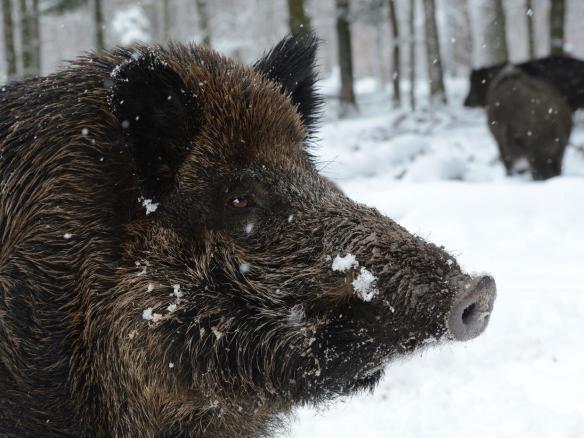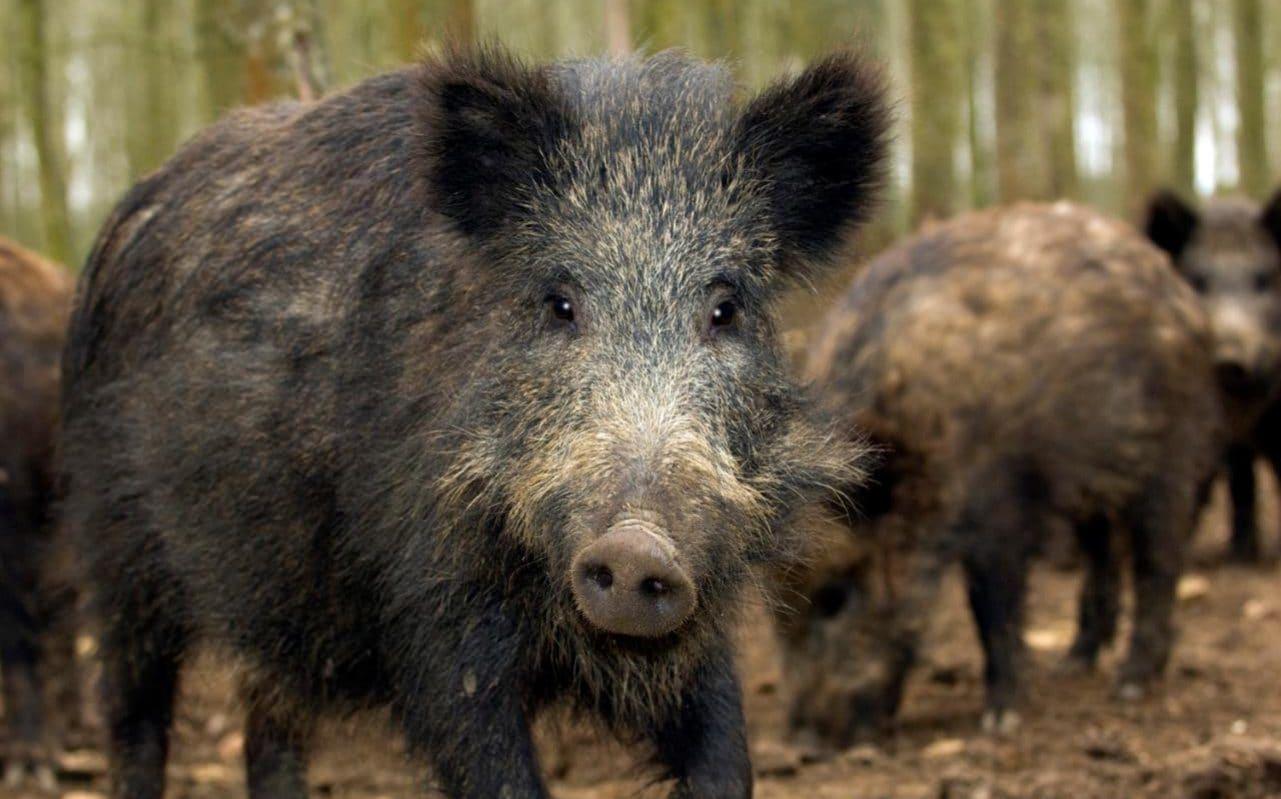The first image is the image on the left, the second image is the image on the right. Examine the images to the left and right. Is the description "The pig in the left image is not alone." accurate? Answer yes or no. No. The first image is the image on the left, the second image is the image on the right. For the images shown, is this caption "A boar is facing forward in one image and to the right in the other." true? Answer yes or no. Yes. 